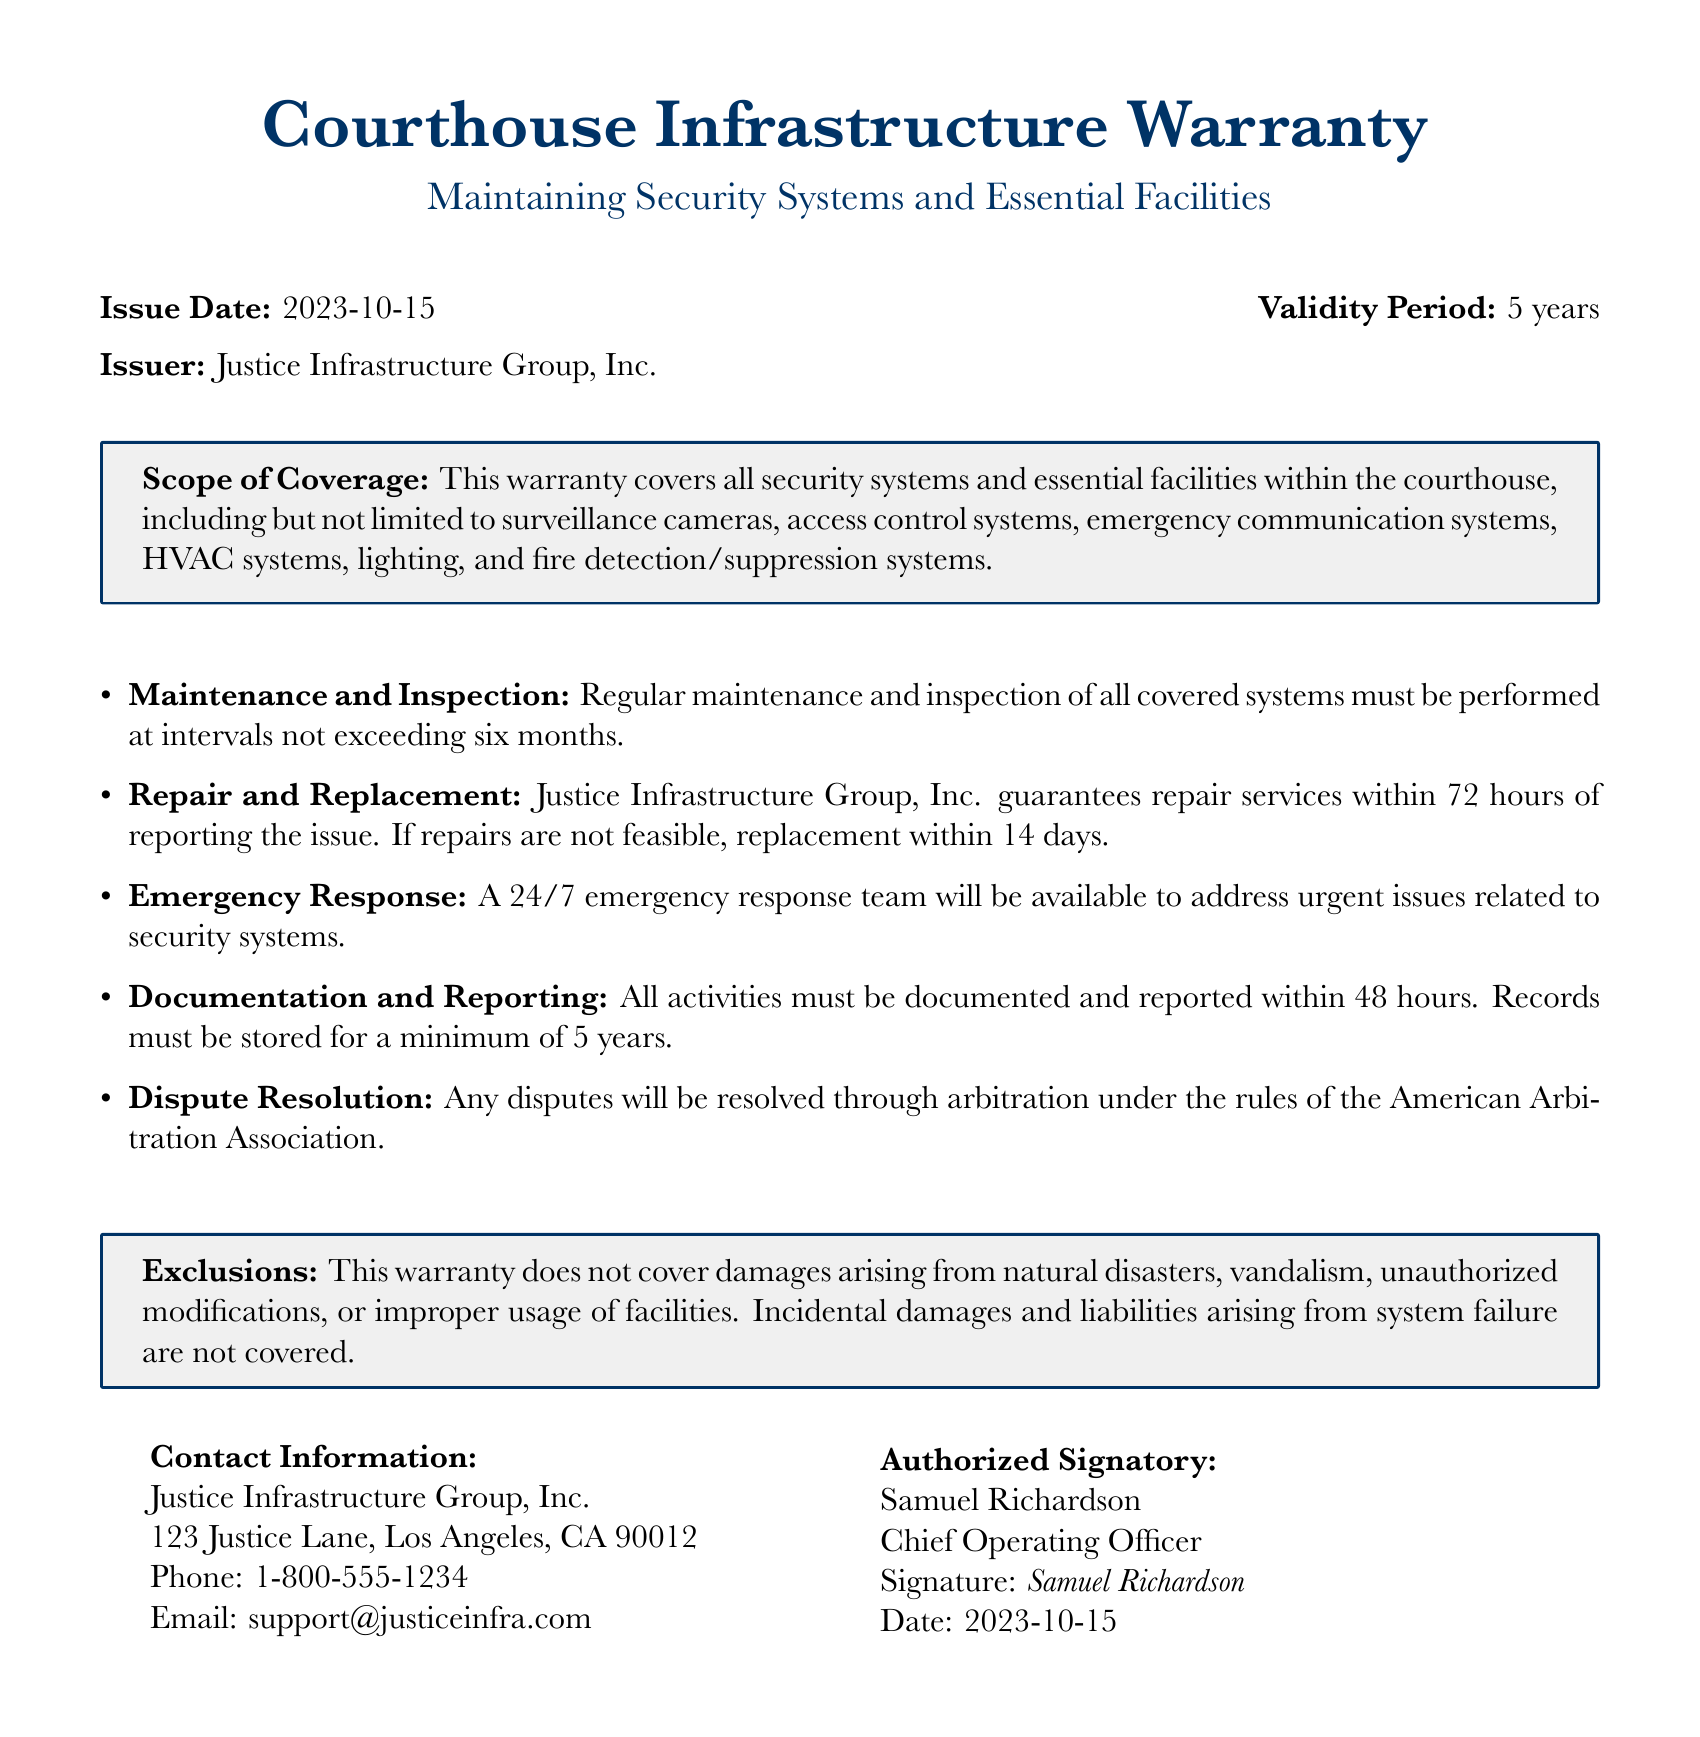What is the issue date of the warranty? The issue date is explicitly stated in the document under the header information
Answer: 2023-10-15 What is the validity period of the warranty? The validity period is mentioned in the same section as the issue date
Answer: 5 years Who is the issuer of the warranty? The issuer is clearly identified in the document
Answer: Justice Infrastructure Group, Inc What is the maximum time for repair services after reporting an issue? The warranty specifies the repair service timeframe in the maintenance and inspection section
Answer: 72 hours How often must maintenance and inspection be performed? The frequency of maintenance and inspection is outlined in the document
Answer: six months What types of systems are covered under the warranty? The scope of coverage provides a list of the systems included
Answer: surveillance cameras, access control systems, emergency communication systems, HVAC systems, lighting, and fire detection/suppression systems What documentation timeline is required for activities? The warranty mentions a specific timeline for documenting and reporting activities
Answer: 48 hours What is the response time for emergency issues? The emergency response section specifies the availability of the team
Answer: 24/7 What types of damages are excluded from the warranty? The exclusions section lists specific scenarios that are not covered
Answer: natural disasters, vandalism, unauthorized modifications, or improper usage of facilities 